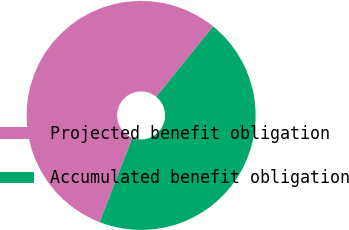<chart> <loc_0><loc_0><loc_500><loc_500><pie_chart><fcel>Projected benefit obligation<fcel>Accumulated benefit obligation<nl><fcel>54.93%<fcel>45.07%<nl></chart> 